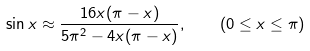Convert formula to latex. <formula><loc_0><loc_0><loc_500><loc_500>\sin x \approx { \frac { 1 6 x ( \pi - x ) } { 5 \pi ^ { 2 } - 4 x ( \pi - x ) } } , \quad ( 0 \leq x \leq \pi )</formula> 